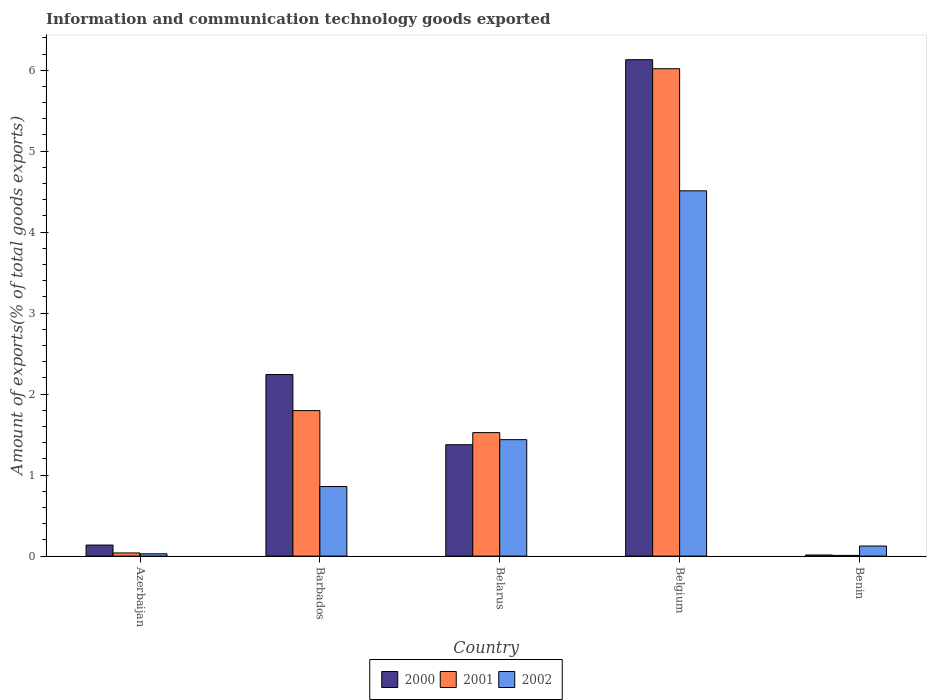Are the number of bars per tick equal to the number of legend labels?
Give a very brief answer. Yes. Are the number of bars on each tick of the X-axis equal?
Your answer should be very brief. Yes. What is the label of the 5th group of bars from the left?
Provide a short and direct response. Benin. In how many cases, is the number of bars for a given country not equal to the number of legend labels?
Your response must be concise. 0. What is the amount of goods exported in 2001 in Belgium?
Give a very brief answer. 6.02. Across all countries, what is the maximum amount of goods exported in 2000?
Ensure brevity in your answer.  6.13. Across all countries, what is the minimum amount of goods exported in 2001?
Your answer should be compact. 0.01. In which country was the amount of goods exported in 2002 maximum?
Provide a short and direct response. Belgium. In which country was the amount of goods exported in 2001 minimum?
Your answer should be compact. Benin. What is the total amount of goods exported in 2002 in the graph?
Offer a terse response. 6.96. What is the difference between the amount of goods exported in 2001 in Azerbaijan and that in Barbados?
Make the answer very short. -1.76. What is the difference between the amount of goods exported in 2002 in Belgium and the amount of goods exported in 2001 in Azerbaijan?
Your answer should be very brief. 4.47. What is the average amount of goods exported in 2001 per country?
Offer a very short reply. 1.88. What is the difference between the amount of goods exported of/in 2000 and amount of goods exported of/in 2002 in Benin?
Provide a succinct answer. -0.11. What is the ratio of the amount of goods exported in 2001 in Azerbaijan to that in Benin?
Offer a terse response. 4.45. Is the amount of goods exported in 2000 in Azerbaijan less than that in Belgium?
Your answer should be very brief. Yes. What is the difference between the highest and the second highest amount of goods exported in 2000?
Make the answer very short. -0.87. What is the difference between the highest and the lowest amount of goods exported in 2002?
Provide a short and direct response. 4.48. In how many countries, is the amount of goods exported in 2001 greater than the average amount of goods exported in 2001 taken over all countries?
Your answer should be compact. 1. What does the 2nd bar from the right in Azerbaijan represents?
Provide a short and direct response. 2001. Is it the case that in every country, the sum of the amount of goods exported in 2002 and amount of goods exported in 2000 is greater than the amount of goods exported in 2001?
Keep it short and to the point. Yes. How many countries are there in the graph?
Keep it short and to the point. 5. What is the difference between two consecutive major ticks on the Y-axis?
Your answer should be compact. 1. Does the graph contain any zero values?
Your answer should be compact. No. Does the graph contain grids?
Your answer should be compact. No. What is the title of the graph?
Offer a terse response. Information and communication technology goods exported. Does "2003" appear as one of the legend labels in the graph?
Ensure brevity in your answer.  No. What is the label or title of the X-axis?
Keep it short and to the point. Country. What is the label or title of the Y-axis?
Your response must be concise. Amount of exports(% of total goods exports). What is the Amount of exports(% of total goods exports) of 2000 in Azerbaijan?
Make the answer very short. 0.14. What is the Amount of exports(% of total goods exports) of 2001 in Azerbaijan?
Offer a very short reply. 0.04. What is the Amount of exports(% of total goods exports) in 2002 in Azerbaijan?
Your answer should be compact. 0.03. What is the Amount of exports(% of total goods exports) of 2000 in Barbados?
Provide a succinct answer. 2.24. What is the Amount of exports(% of total goods exports) in 2001 in Barbados?
Your answer should be compact. 1.8. What is the Amount of exports(% of total goods exports) of 2002 in Barbados?
Make the answer very short. 0.86. What is the Amount of exports(% of total goods exports) in 2000 in Belarus?
Your response must be concise. 1.38. What is the Amount of exports(% of total goods exports) in 2001 in Belarus?
Ensure brevity in your answer.  1.53. What is the Amount of exports(% of total goods exports) of 2002 in Belarus?
Make the answer very short. 1.44. What is the Amount of exports(% of total goods exports) in 2000 in Belgium?
Ensure brevity in your answer.  6.13. What is the Amount of exports(% of total goods exports) in 2001 in Belgium?
Keep it short and to the point. 6.02. What is the Amount of exports(% of total goods exports) in 2002 in Belgium?
Give a very brief answer. 4.51. What is the Amount of exports(% of total goods exports) in 2000 in Benin?
Give a very brief answer. 0.01. What is the Amount of exports(% of total goods exports) in 2001 in Benin?
Your answer should be compact. 0.01. What is the Amount of exports(% of total goods exports) of 2002 in Benin?
Your answer should be very brief. 0.12. Across all countries, what is the maximum Amount of exports(% of total goods exports) in 2000?
Offer a very short reply. 6.13. Across all countries, what is the maximum Amount of exports(% of total goods exports) of 2001?
Make the answer very short. 6.02. Across all countries, what is the maximum Amount of exports(% of total goods exports) of 2002?
Your answer should be compact. 4.51. Across all countries, what is the minimum Amount of exports(% of total goods exports) in 2000?
Provide a short and direct response. 0.01. Across all countries, what is the minimum Amount of exports(% of total goods exports) in 2001?
Offer a very short reply. 0.01. Across all countries, what is the minimum Amount of exports(% of total goods exports) of 2002?
Make the answer very short. 0.03. What is the total Amount of exports(% of total goods exports) in 2000 in the graph?
Give a very brief answer. 9.9. What is the total Amount of exports(% of total goods exports) in 2001 in the graph?
Offer a terse response. 9.39. What is the total Amount of exports(% of total goods exports) of 2002 in the graph?
Ensure brevity in your answer.  6.96. What is the difference between the Amount of exports(% of total goods exports) in 2000 in Azerbaijan and that in Barbados?
Your answer should be very brief. -2.11. What is the difference between the Amount of exports(% of total goods exports) in 2001 in Azerbaijan and that in Barbados?
Your answer should be compact. -1.76. What is the difference between the Amount of exports(% of total goods exports) of 2002 in Azerbaijan and that in Barbados?
Your answer should be very brief. -0.83. What is the difference between the Amount of exports(% of total goods exports) of 2000 in Azerbaijan and that in Belarus?
Your answer should be compact. -1.24. What is the difference between the Amount of exports(% of total goods exports) of 2001 in Azerbaijan and that in Belarus?
Give a very brief answer. -1.49. What is the difference between the Amount of exports(% of total goods exports) in 2002 in Azerbaijan and that in Belarus?
Your response must be concise. -1.41. What is the difference between the Amount of exports(% of total goods exports) in 2000 in Azerbaijan and that in Belgium?
Your answer should be very brief. -5.99. What is the difference between the Amount of exports(% of total goods exports) of 2001 in Azerbaijan and that in Belgium?
Your answer should be compact. -5.98. What is the difference between the Amount of exports(% of total goods exports) of 2002 in Azerbaijan and that in Belgium?
Offer a very short reply. -4.48. What is the difference between the Amount of exports(% of total goods exports) in 2000 in Azerbaijan and that in Benin?
Provide a short and direct response. 0.12. What is the difference between the Amount of exports(% of total goods exports) in 2001 in Azerbaijan and that in Benin?
Offer a very short reply. 0.03. What is the difference between the Amount of exports(% of total goods exports) of 2002 in Azerbaijan and that in Benin?
Your response must be concise. -0.1. What is the difference between the Amount of exports(% of total goods exports) in 2000 in Barbados and that in Belarus?
Ensure brevity in your answer.  0.87. What is the difference between the Amount of exports(% of total goods exports) in 2001 in Barbados and that in Belarus?
Keep it short and to the point. 0.27. What is the difference between the Amount of exports(% of total goods exports) in 2002 in Barbados and that in Belarus?
Provide a short and direct response. -0.58. What is the difference between the Amount of exports(% of total goods exports) in 2000 in Barbados and that in Belgium?
Offer a terse response. -3.89. What is the difference between the Amount of exports(% of total goods exports) of 2001 in Barbados and that in Belgium?
Ensure brevity in your answer.  -4.22. What is the difference between the Amount of exports(% of total goods exports) in 2002 in Barbados and that in Belgium?
Your answer should be compact. -3.65. What is the difference between the Amount of exports(% of total goods exports) in 2000 in Barbados and that in Benin?
Make the answer very short. 2.23. What is the difference between the Amount of exports(% of total goods exports) in 2001 in Barbados and that in Benin?
Offer a very short reply. 1.79. What is the difference between the Amount of exports(% of total goods exports) in 2002 in Barbados and that in Benin?
Your response must be concise. 0.73. What is the difference between the Amount of exports(% of total goods exports) in 2000 in Belarus and that in Belgium?
Your answer should be compact. -4.75. What is the difference between the Amount of exports(% of total goods exports) in 2001 in Belarus and that in Belgium?
Keep it short and to the point. -4.49. What is the difference between the Amount of exports(% of total goods exports) in 2002 in Belarus and that in Belgium?
Provide a short and direct response. -3.07. What is the difference between the Amount of exports(% of total goods exports) of 2000 in Belarus and that in Benin?
Ensure brevity in your answer.  1.36. What is the difference between the Amount of exports(% of total goods exports) of 2001 in Belarus and that in Benin?
Keep it short and to the point. 1.52. What is the difference between the Amount of exports(% of total goods exports) of 2002 in Belarus and that in Benin?
Provide a succinct answer. 1.31. What is the difference between the Amount of exports(% of total goods exports) in 2000 in Belgium and that in Benin?
Your answer should be compact. 6.12. What is the difference between the Amount of exports(% of total goods exports) in 2001 in Belgium and that in Benin?
Make the answer very short. 6.01. What is the difference between the Amount of exports(% of total goods exports) in 2002 in Belgium and that in Benin?
Offer a terse response. 4.39. What is the difference between the Amount of exports(% of total goods exports) in 2000 in Azerbaijan and the Amount of exports(% of total goods exports) in 2001 in Barbados?
Offer a terse response. -1.66. What is the difference between the Amount of exports(% of total goods exports) of 2000 in Azerbaijan and the Amount of exports(% of total goods exports) of 2002 in Barbados?
Ensure brevity in your answer.  -0.72. What is the difference between the Amount of exports(% of total goods exports) of 2001 in Azerbaijan and the Amount of exports(% of total goods exports) of 2002 in Barbados?
Your answer should be very brief. -0.82. What is the difference between the Amount of exports(% of total goods exports) in 2000 in Azerbaijan and the Amount of exports(% of total goods exports) in 2001 in Belarus?
Ensure brevity in your answer.  -1.39. What is the difference between the Amount of exports(% of total goods exports) in 2000 in Azerbaijan and the Amount of exports(% of total goods exports) in 2002 in Belarus?
Give a very brief answer. -1.3. What is the difference between the Amount of exports(% of total goods exports) in 2001 in Azerbaijan and the Amount of exports(% of total goods exports) in 2002 in Belarus?
Your answer should be very brief. -1.4. What is the difference between the Amount of exports(% of total goods exports) of 2000 in Azerbaijan and the Amount of exports(% of total goods exports) of 2001 in Belgium?
Offer a very short reply. -5.88. What is the difference between the Amount of exports(% of total goods exports) of 2000 in Azerbaijan and the Amount of exports(% of total goods exports) of 2002 in Belgium?
Your response must be concise. -4.37. What is the difference between the Amount of exports(% of total goods exports) in 2001 in Azerbaijan and the Amount of exports(% of total goods exports) in 2002 in Belgium?
Make the answer very short. -4.47. What is the difference between the Amount of exports(% of total goods exports) in 2000 in Azerbaijan and the Amount of exports(% of total goods exports) in 2001 in Benin?
Make the answer very short. 0.13. What is the difference between the Amount of exports(% of total goods exports) of 2000 in Azerbaijan and the Amount of exports(% of total goods exports) of 2002 in Benin?
Ensure brevity in your answer.  0.01. What is the difference between the Amount of exports(% of total goods exports) of 2001 in Azerbaijan and the Amount of exports(% of total goods exports) of 2002 in Benin?
Ensure brevity in your answer.  -0.09. What is the difference between the Amount of exports(% of total goods exports) in 2000 in Barbados and the Amount of exports(% of total goods exports) in 2001 in Belarus?
Keep it short and to the point. 0.72. What is the difference between the Amount of exports(% of total goods exports) in 2000 in Barbados and the Amount of exports(% of total goods exports) in 2002 in Belarus?
Make the answer very short. 0.8. What is the difference between the Amount of exports(% of total goods exports) of 2001 in Barbados and the Amount of exports(% of total goods exports) of 2002 in Belarus?
Provide a succinct answer. 0.36. What is the difference between the Amount of exports(% of total goods exports) in 2000 in Barbados and the Amount of exports(% of total goods exports) in 2001 in Belgium?
Offer a very short reply. -3.78. What is the difference between the Amount of exports(% of total goods exports) in 2000 in Barbados and the Amount of exports(% of total goods exports) in 2002 in Belgium?
Offer a terse response. -2.27. What is the difference between the Amount of exports(% of total goods exports) of 2001 in Barbados and the Amount of exports(% of total goods exports) of 2002 in Belgium?
Keep it short and to the point. -2.71. What is the difference between the Amount of exports(% of total goods exports) in 2000 in Barbados and the Amount of exports(% of total goods exports) in 2001 in Benin?
Offer a very short reply. 2.23. What is the difference between the Amount of exports(% of total goods exports) of 2000 in Barbados and the Amount of exports(% of total goods exports) of 2002 in Benin?
Your answer should be compact. 2.12. What is the difference between the Amount of exports(% of total goods exports) in 2001 in Barbados and the Amount of exports(% of total goods exports) in 2002 in Benin?
Your response must be concise. 1.67. What is the difference between the Amount of exports(% of total goods exports) in 2000 in Belarus and the Amount of exports(% of total goods exports) in 2001 in Belgium?
Your response must be concise. -4.64. What is the difference between the Amount of exports(% of total goods exports) in 2000 in Belarus and the Amount of exports(% of total goods exports) in 2002 in Belgium?
Your response must be concise. -3.14. What is the difference between the Amount of exports(% of total goods exports) of 2001 in Belarus and the Amount of exports(% of total goods exports) of 2002 in Belgium?
Keep it short and to the point. -2.99. What is the difference between the Amount of exports(% of total goods exports) in 2000 in Belarus and the Amount of exports(% of total goods exports) in 2001 in Benin?
Your response must be concise. 1.37. What is the difference between the Amount of exports(% of total goods exports) in 2000 in Belarus and the Amount of exports(% of total goods exports) in 2002 in Benin?
Provide a succinct answer. 1.25. What is the difference between the Amount of exports(% of total goods exports) of 2001 in Belarus and the Amount of exports(% of total goods exports) of 2002 in Benin?
Your response must be concise. 1.4. What is the difference between the Amount of exports(% of total goods exports) in 2000 in Belgium and the Amount of exports(% of total goods exports) in 2001 in Benin?
Offer a very short reply. 6.12. What is the difference between the Amount of exports(% of total goods exports) in 2000 in Belgium and the Amount of exports(% of total goods exports) in 2002 in Benin?
Your response must be concise. 6.01. What is the difference between the Amount of exports(% of total goods exports) of 2001 in Belgium and the Amount of exports(% of total goods exports) of 2002 in Benin?
Your response must be concise. 5.89. What is the average Amount of exports(% of total goods exports) in 2000 per country?
Your answer should be very brief. 1.98. What is the average Amount of exports(% of total goods exports) in 2001 per country?
Your response must be concise. 1.88. What is the average Amount of exports(% of total goods exports) of 2002 per country?
Your response must be concise. 1.39. What is the difference between the Amount of exports(% of total goods exports) in 2000 and Amount of exports(% of total goods exports) in 2001 in Azerbaijan?
Your answer should be compact. 0.1. What is the difference between the Amount of exports(% of total goods exports) in 2000 and Amount of exports(% of total goods exports) in 2002 in Azerbaijan?
Provide a succinct answer. 0.11. What is the difference between the Amount of exports(% of total goods exports) of 2001 and Amount of exports(% of total goods exports) of 2002 in Azerbaijan?
Your answer should be very brief. 0.01. What is the difference between the Amount of exports(% of total goods exports) in 2000 and Amount of exports(% of total goods exports) in 2001 in Barbados?
Give a very brief answer. 0.45. What is the difference between the Amount of exports(% of total goods exports) of 2000 and Amount of exports(% of total goods exports) of 2002 in Barbados?
Provide a succinct answer. 1.38. What is the difference between the Amount of exports(% of total goods exports) of 2001 and Amount of exports(% of total goods exports) of 2002 in Barbados?
Your answer should be very brief. 0.94. What is the difference between the Amount of exports(% of total goods exports) of 2000 and Amount of exports(% of total goods exports) of 2001 in Belarus?
Keep it short and to the point. -0.15. What is the difference between the Amount of exports(% of total goods exports) of 2000 and Amount of exports(% of total goods exports) of 2002 in Belarus?
Ensure brevity in your answer.  -0.06. What is the difference between the Amount of exports(% of total goods exports) of 2001 and Amount of exports(% of total goods exports) of 2002 in Belarus?
Provide a short and direct response. 0.09. What is the difference between the Amount of exports(% of total goods exports) of 2000 and Amount of exports(% of total goods exports) of 2001 in Belgium?
Provide a succinct answer. 0.11. What is the difference between the Amount of exports(% of total goods exports) in 2000 and Amount of exports(% of total goods exports) in 2002 in Belgium?
Your response must be concise. 1.62. What is the difference between the Amount of exports(% of total goods exports) in 2001 and Amount of exports(% of total goods exports) in 2002 in Belgium?
Keep it short and to the point. 1.51. What is the difference between the Amount of exports(% of total goods exports) of 2000 and Amount of exports(% of total goods exports) of 2001 in Benin?
Keep it short and to the point. 0.01. What is the difference between the Amount of exports(% of total goods exports) of 2000 and Amount of exports(% of total goods exports) of 2002 in Benin?
Give a very brief answer. -0.11. What is the difference between the Amount of exports(% of total goods exports) in 2001 and Amount of exports(% of total goods exports) in 2002 in Benin?
Your answer should be very brief. -0.12. What is the ratio of the Amount of exports(% of total goods exports) of 2000 in Azerbaijan to that in Barbados?
Provide a succinct answer. 0.06. What is the ratio of the Amount of exports(% of total goods exports) in 2001 in Azerbaijan to that in Barbados?
Give a very brief answer. 0.02. What is the ratio of the Amount of exports(% of total goods exports) of 2002 in Azerbaijan to that in Barbados?
Ensure brevity in your answer.  0.03. What is the ratio of the Amount of exports(% of total goods exports) in 2000 in Azerbaijan to that in Belarus?
Ensure brevity in your answer.  0.1. What is the ratio of the Amount of exports(% of total goods exports) of 2001 in Azerbaijan to that in Belarus?
Offer a terse response. 0.03. What is the ratio of the Amount of exports(% of total goods exports) in 2002 in Azerbaijan to that in Belarus?
Keep it short and to the point. 0.02. What is the ratio of the Amount of exports(% of total goods exports) in 2000 in Azerbaijan to that in Belgium?
Your answer should be compact. 0.02. What is the ratio of the Amount of exports(% of total goods exports) in 2001 in Azerbaijan to that in Belgium?
Offer a terse response. 0.01. What is the ratio of the Amount of exports(% of total goods exports) of 2002 in Azerbaijan to that in Belgium?
Your response must be concise. 0.01. What is the ratio of the Amount of exports(% of total goods exports) of 2000 in Azerbaijan to that in Benin?
Ensure brevity in your answer.  9.86. What is the ratio of the Amount of exports(% of total goods exports) of 2001 in Azerbaijan to that in Benin?
Give a very brief answer. 4.45. What is the ratio of the Amount of exports(% of total goods exports) in 2002 in Azerbaijan to that in Benin?
Your response must be concise. 0.23. What is the ratio of the Amount of exports(% of total goods exports) in 2000 in Barbados to that in Belarus?
Ensure brevity in your answer.  1.63. What is the ratio of the Amount of exports(% of total goods exports) in 2001 in Barbados to that in Belarus?
Your answer should be compact. 1.18. What is the ratio of the Amount of exports(% of total goods exports) in 2002 in Barbados to that in Belarus?
Your response must be concise. 0.6. What is the ratio of the Amount of exports(% of total goods exports) in 2000 in Barbados to that in Belgium?
Your response must be concise. 0.37. What is the ratio of the Amount of exports(% of total goods exports) of 2001 in Barbados to that in Belgium?
Your answer should be compact. 0.3. What is the ratio of the Amount of exports(% of total goods exports) in 2002 in Barbados to that in Belgium?
Your response must be concise. 0.19. What is the ratio of the Amount of exports(% of total goods exports) in 2000 in Barbados to that in Benin?
Give a very brief answer. 162.08. What is the ratio of the Amount of exports(% of total goods exports) of 2001 in Barbados to that in Benin?
Keep it short and to the point. 205.42. What is the ratio of the Amount of exports(% of total goods exports) in 2002 in Barbados to that in Benin?
Give a very brief answer. 6.91. What is the ratio of the Amount of exports(% of total goods exports) of 2000 in Belarus to that in Belgium?
Provide a short and direct response. 0.22. What is the ratio of the Amount of exports(% of total goods exports) of 2001 in Belarus to that in Belgium?
Offer a very short reply. 0.25. What is the ratio of the Amount of exports(% of total goods exports) in 2002 in Belarus to that in Belgium?
Keep it short and to the point. 0.32. What is the ratio of the Amount of exports(% of total goods exports) in 2000 in Belarus to that in Benin?
Your answer should be compact. 99.4. What is the ratio of the Amount of exports(% of total goods exports) in 2001 in Belarus to that in Benin?
Offer a very short reply. 174.35. What is the ratio of the Amount of exports(% of total goods exports) in 2002 in Belarus to that in Benin?
Offer a very short reply. 11.56. What is the ratio of the Amount of exports(% of total goods exports) in 2000 in Belgium to that in Benin?
Offer a very short reply. 443.09. What is the ratio of the Amount of exports(% of total goods exports) of 2001 in Belgium to that in Benin?
Provide a succinct answer. 688.06. What is the ratio of the Amount of exports(% of total goods exports) of 2002 in Belgium to that in Benin?
Make the answer very short. 36.26. What is the difference between the highest and the second highest Amount of exports(% of total goods exports) in 2000?
Offer a terse response. 3.89. What is the difference between the highest and the second highest Amount of exports(% of total goods exports) in 2001?
Provide a short and direct response. 4.22. What is the difference between the highest and the second highest Amount of exports(% of total goods exports) of 2002?
Offer a terse response. 3.07. What is the difference between the highest and the lowest Amount of exports(% of total goods exports) in 2000?
Give a very brief answer. 6.12. What is the difference between the highest and the lowest Amount of exports(% of total goods exports) of 2001?
Give a very brief answer. 6.01. What is the difference between the highest and the lowest Amount of exports(% of total goods exports) in 2002?
Offer a very short reply. 4.48. 